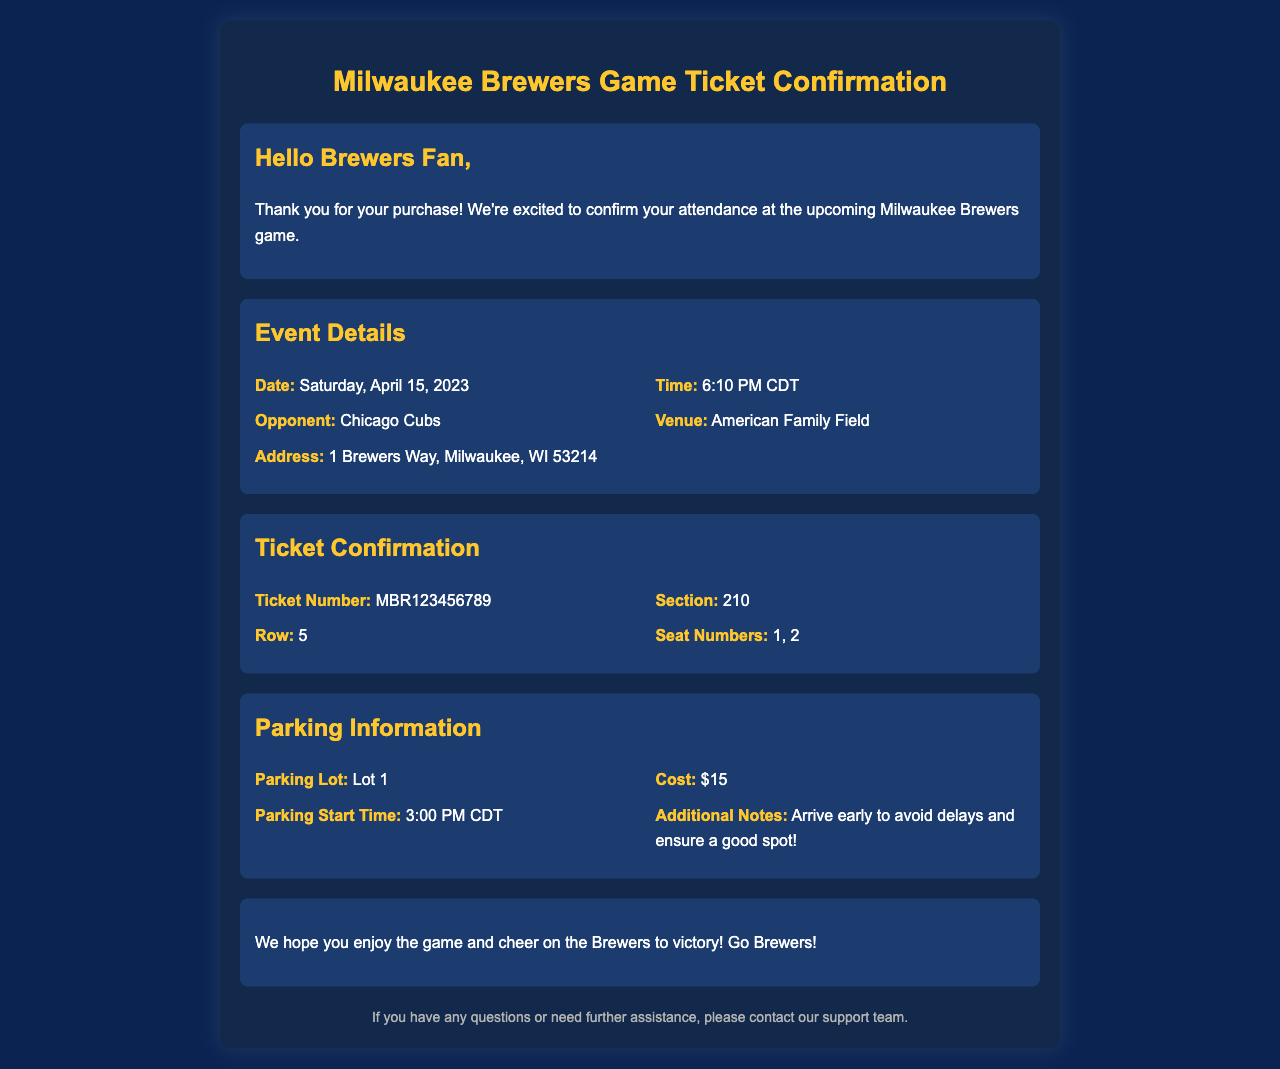What is the date of the game? The date of the game is mentioned in the event details section of the document.
Answer: Saturday, April 15, 2023 What time does the game start? The start time of the game is specified right next to the date in the event details.
Answer: 6:10 PM CDT Who is the opponent for the game? The opponent is listed under event details where it states the matchup for the game.
Answer: Chicago Cubs What is the ticket number? The ticket number is provided in the ticket confirmation section of the document.
Answer: MBR123456789 What is the parking cost? The parking cost is detailed in the parking information section of the document.
Answer: $15 What section is the ticket located in? The section of the ticket is specified in the ticket confirmation part of the document.
Answer: 210 What time does parking start? The parking start time is mentioned in the parking information details.
Answer: 3:00 PM CDT What should you do to avoid delays? This recommendation is made in the parking information section of the document.
Answer: Arrive early 